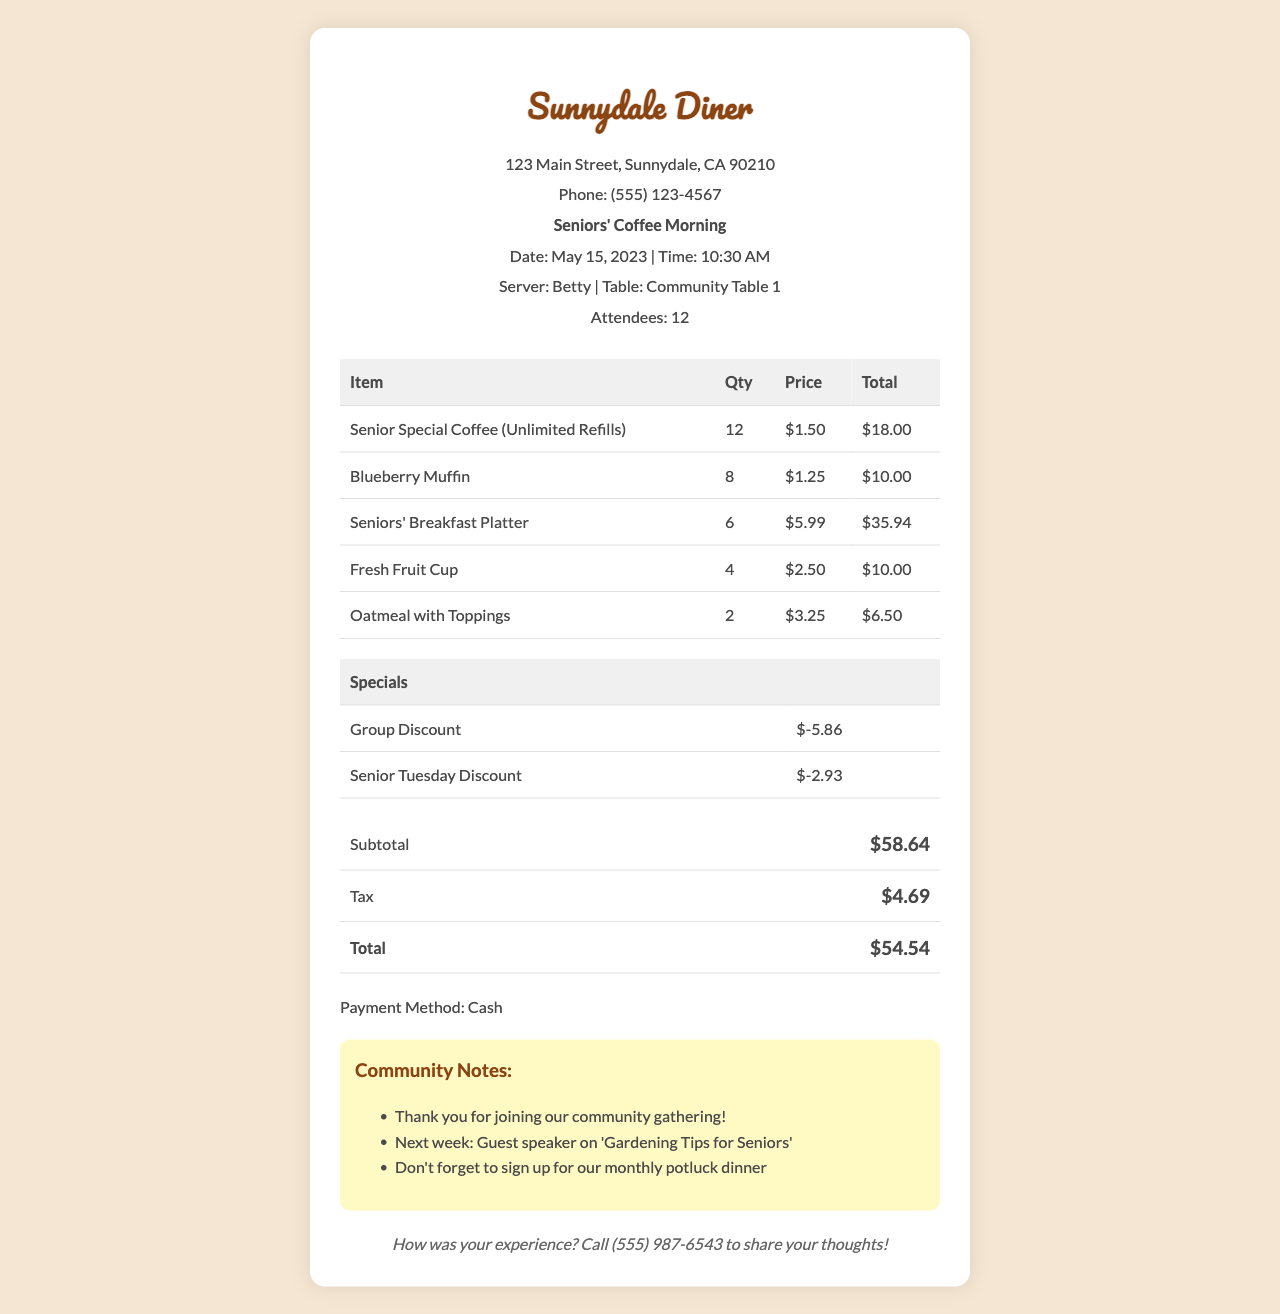What is the name of the diner? The diner is referred to as Sunnydale Diner in the document.
Answer: Sunnydale Diner What date was the Seniors' Coffee Morning held? The specific date of the event is stated as May 15, 2023.
Answer: May 15, 2023 How many attendees were present at the gathering? The number of attendees is clearly listed as 12 in the document.
Answer: 12 What was the price of the Senior Special Coffee? The price for a single Senior Special Coffee is provided as $1.50.
Answer: $1.50 What is the total amount charged after discounts? The total after applying specials is explicitly stated as $54.54.
Answer: $54.54 What type of discount was applied for groups? The document mentions a Group Discount specifically for groups of 10 or more.
Answer: Group Discount How many Blueberry Muffins were ordered? The document lists the quantity of Blueberry Muffins as 8.
Answer: 8 Who was the server for the event? The server's name is mentioned as Betty in the document.
Answer: Betty What special event is scheduled for next week? The notes mention a guest speaker discussing 'Gardening Tips for Seniors' as the upcoming event.
Answer: Guest speaker on 'Gardening Tips for Seniors' 